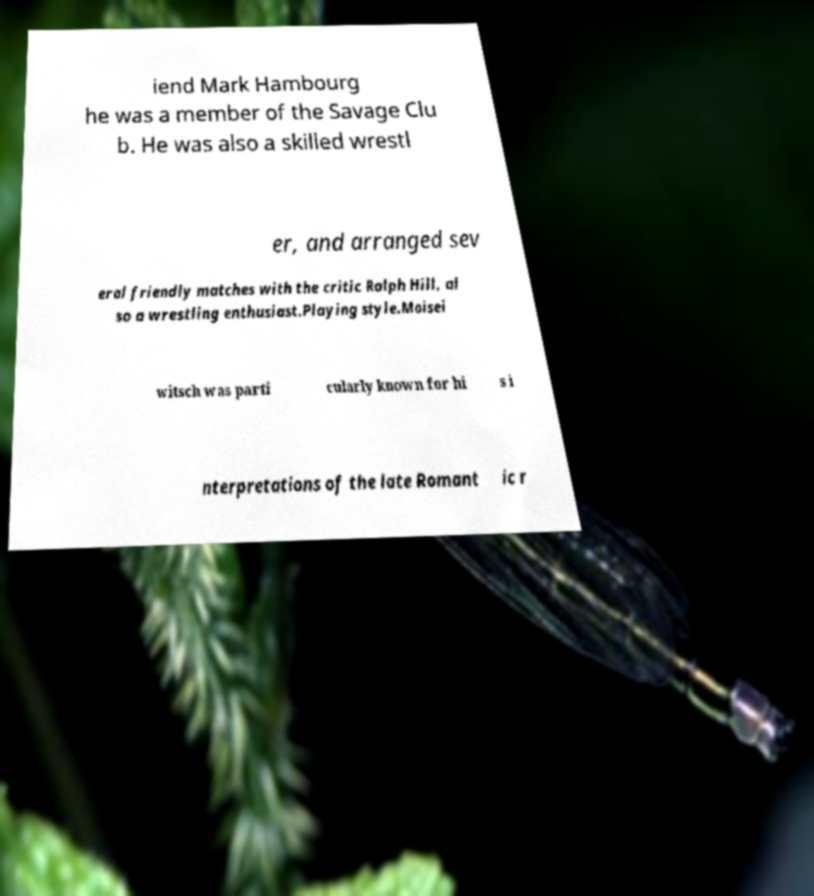What messages or text are displayed in this image? I need them in a readable, typed format. iend Mark Hambourg he was a member of the Savage Clu b. He was also a skilled wrestl er, and arranged sev eral friendly matches with the critic Ralph Hill, al so a wrestling enthusiast.Playing style.Moisei witsch was parti cularly known for hi s i nterpretations of the late Romant ic r 